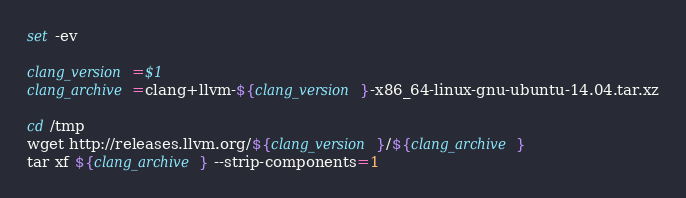Convert code to text. <code><loc_0><loc_0><loc_500><loc_500><_Bash_>set -ev

clang_version=$1
clang_archive=clang+llvm-${clang_version}-x86_64-linux-gnu-ubuntu-14.04.tar.xz

cd /tmp
wget http://releases.llvm.org/${clang_version}/${clang_archive}
tar xf ${clang_archive} --strip-components=1
</code> 